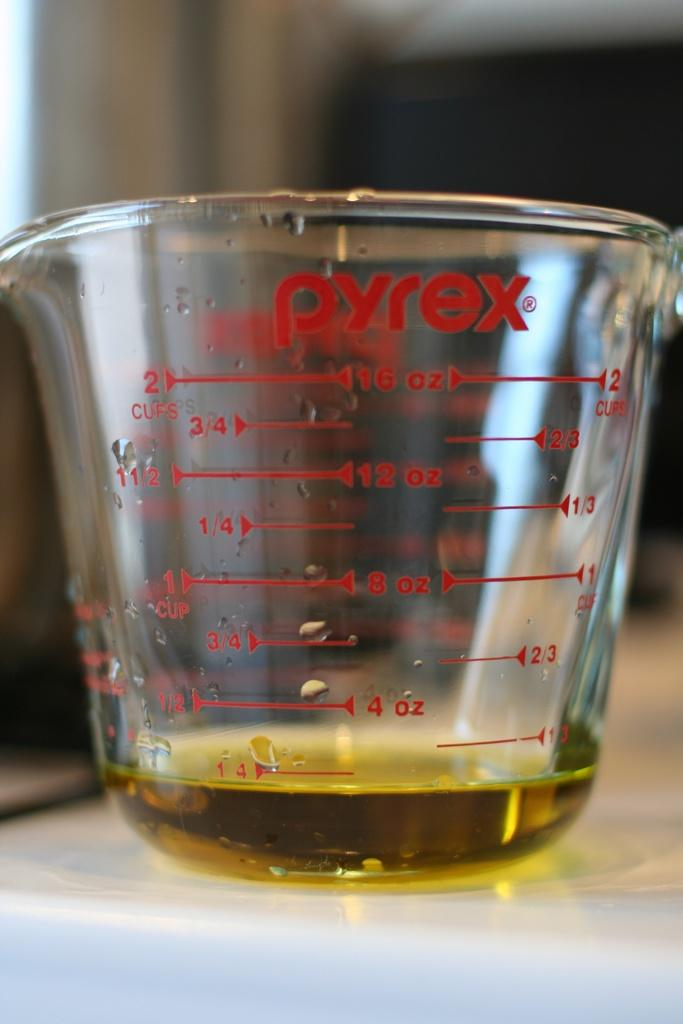<image>
Share a concise interpretation of the image provided. Pyrex measuring cup that measures cups and ounces. 